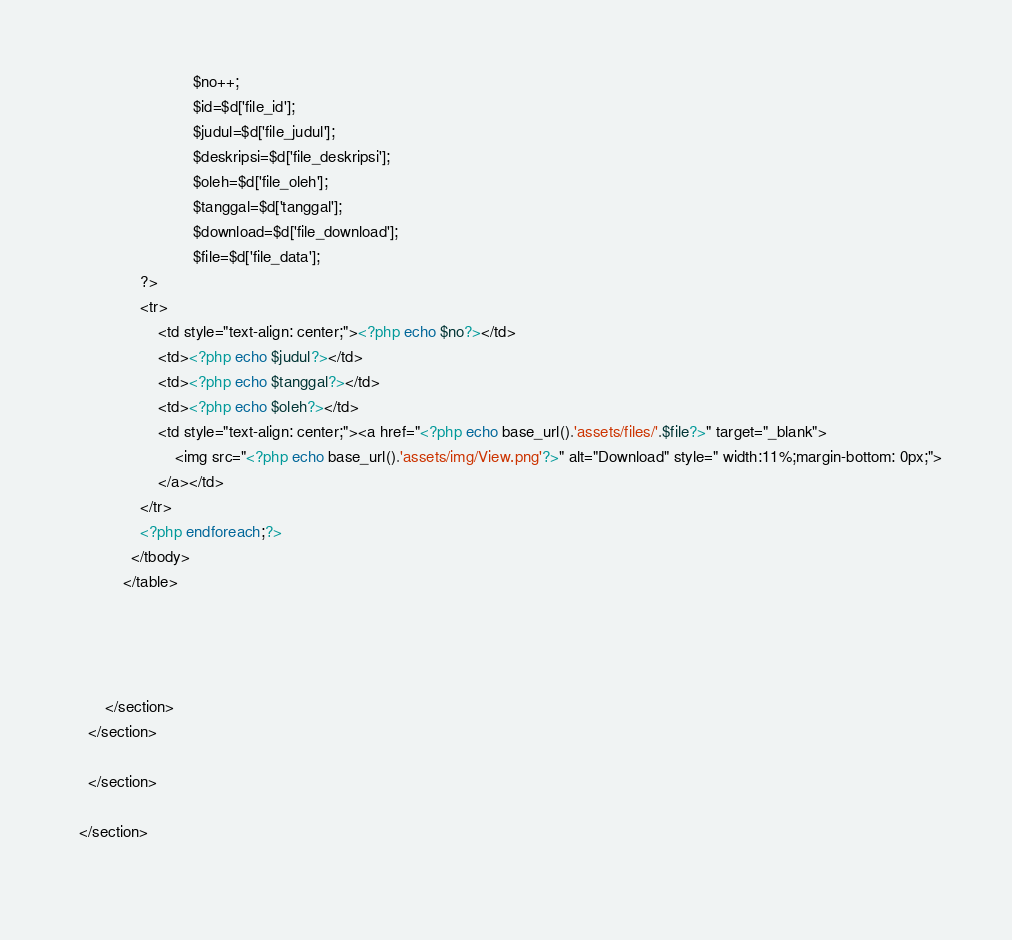Convert code to text. <code><loc_0><loc_0><loc_500><loc_500><_PHP_>                            $no++;
                            $id=$d['file_id'];
                            $judul=$d['file_judul'];
                            $deskripsi=$d['file_deskripsi'];
                            $oleh=$d['file_oleh'];
                            $tanggal=$d['tanggal'];
                            $download=$d['file_download'];
                            $file=$d['file_data'];
                ?>
          		<tr>
          			<td style="text-align: center;"><?php echo $no?></td>
          			<td><?php echo $judul?></td>
          			<td><?php echo $tanggal?></td>
          			<td><?php echo $oleh?></td>
          			<td style="text-align: center;"><a href="<?php echo base_url().'assets/files/'.$file?>" target="_blank">
          				<img src="<?php echo base_url().'assets/img/View.png'?>" alt="Download" style=" width:11%;margin-bottom: 0px;">
          			</a></td>
          		</tr>
          		<?php endforeach;?>
              </tbody>
            </table>
			
			

	
		</section>
	</section>
   
	</section>
 
  </section>
  </code> 